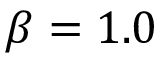Convert formula to latex. <formula><loc_0><loc_0><loc_500><loc_500>\beta = 1 . 0</formula> 